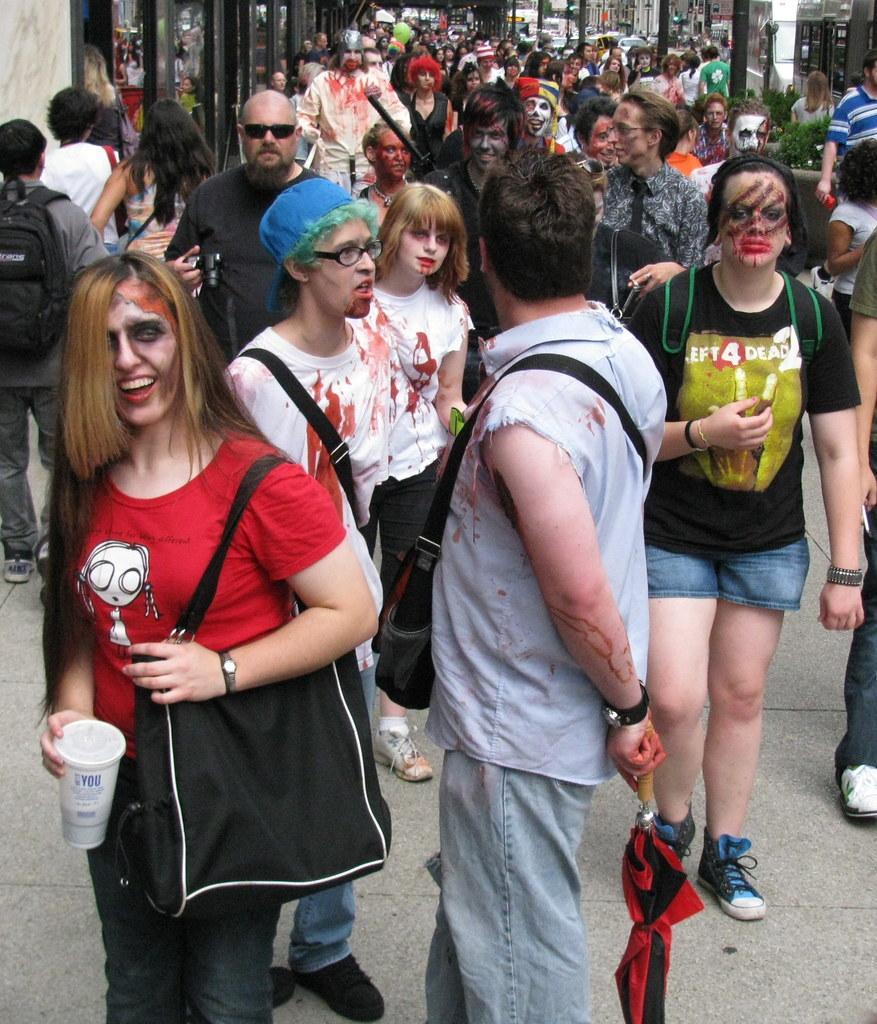Where was the image taken? The image was taken outside on a street. What can be seen on the street in the image? There are many people on the street in the image. What is visible on the left side of the image? There are glass windows and a wall on the left side of the image. What is visible on the right side of the image? There are buildings and a pole on the right side of the image. What type of plough is being used by the people in the image? There is no plough present in the image; it is taken on a street with people and buildings. What do the people in the image believe about the payment for their services? There is no information about beliefs or payments in the image, as it only shows people on a street with buildings and a pole. 